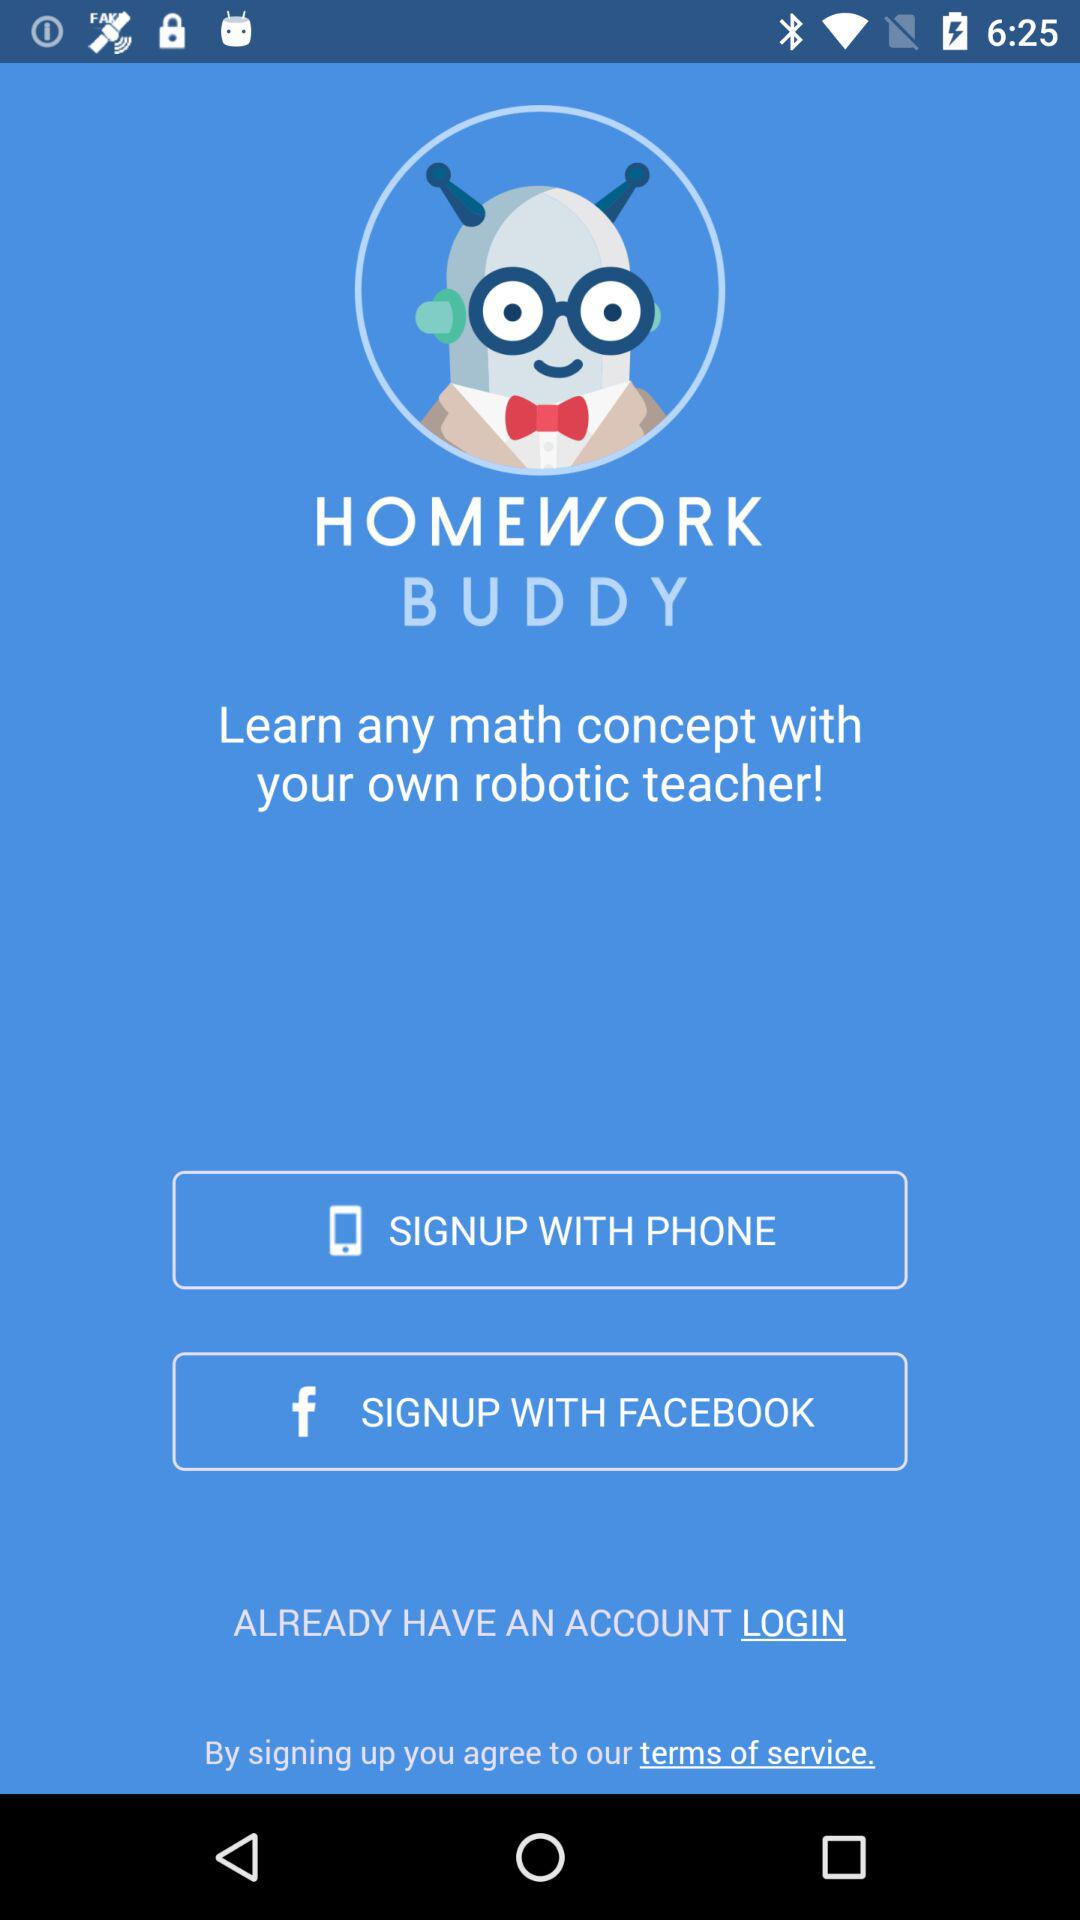What is the application name? The application name is "HOMEWORK BUDDY". 